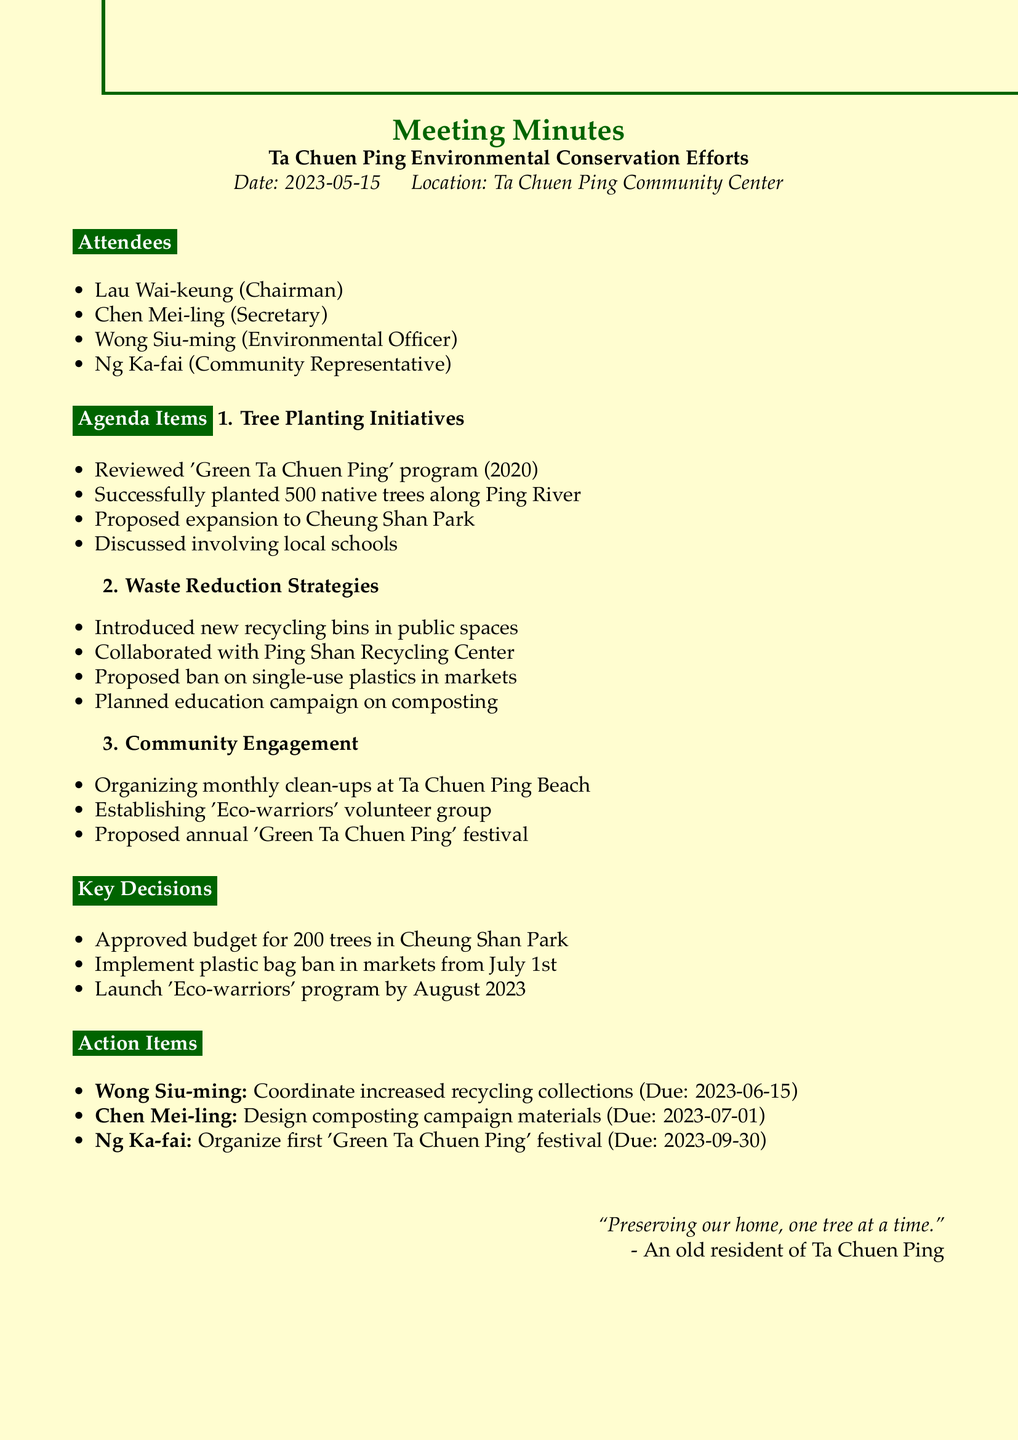What is the date of the meeting? The date of the meeting is specified in the document, which is May 15, 2023.
Answer: May 15, 2023 Who is the Environmental Officer? The Environmental Officer is listed among the attendees of the meeting, identified as Wong Siu-ming.
Answer: Wong Siu-ming How many trees were successfully planted along Ping River? The document reports the success of planting 500 native trees along Ping River as part of the tree planting initiatives.
Answer: 500 What is proposed to start on July 1st? The document states the decision to implement a plastic bag ban in local markets starting July 1st.
Answer: Plastic bag ban Who is responsible for coordinating with the Ping Shan Recycling Center? The responsible individual for coordinating increased recycling collections is noted as Wong Siu-ming in the action items.
Answer: Wong Siu-ming What type of group is being established for community engagement? The document outlines the establishment of an 'Eco-warriors' volunteer group as part of the community engagement efforts.
Answer: Eco-warriors How many additional trees are planned for Cheung Shan Park? The key decision mentions approving a budget for planting 200 additional trees in Cheung Shan Park.
Answer: 200 What festival is proposed to be organized annually? An annual 'Green Ta Chuen Ping' festival is proposed as part of the community engagement agenda items.
Answer: Green Ta Chuen Ping festival 